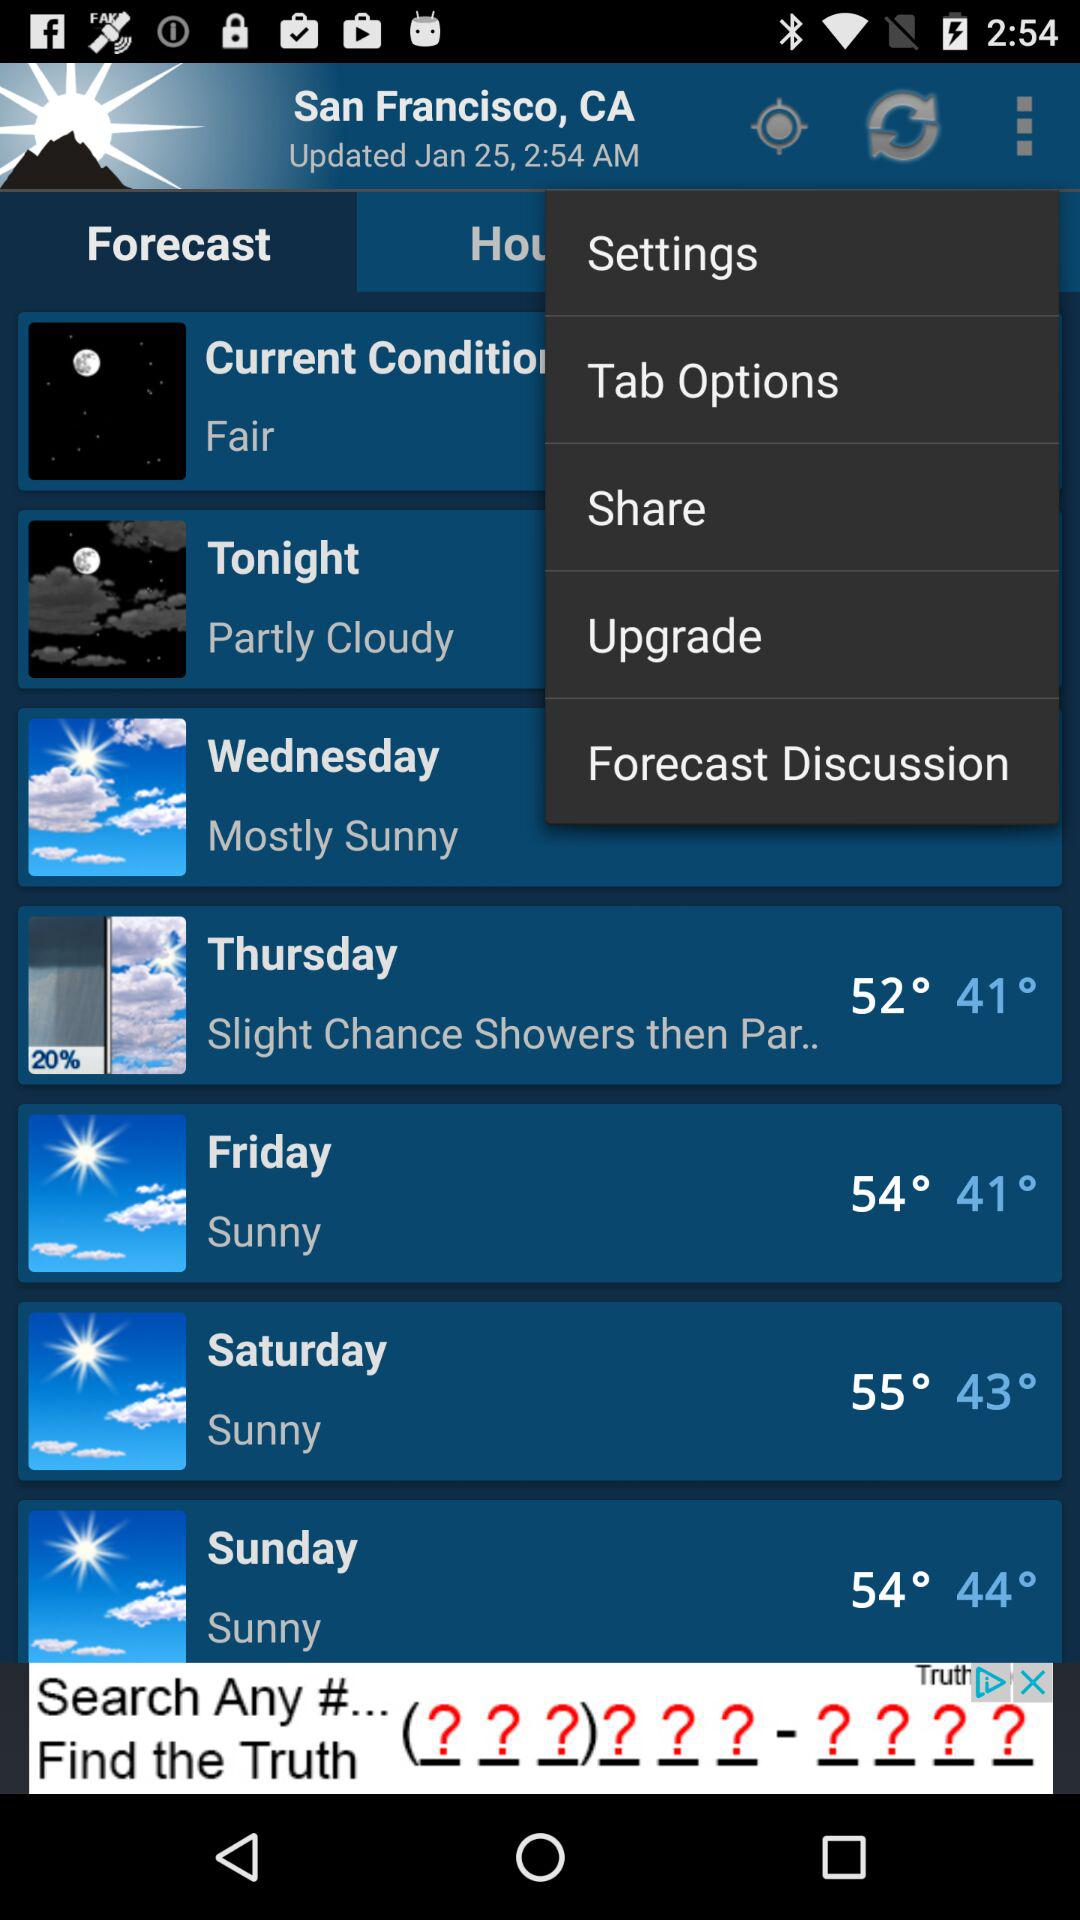What will be the temperature on Sunday? The temperature range will be between 54° and 44°. 